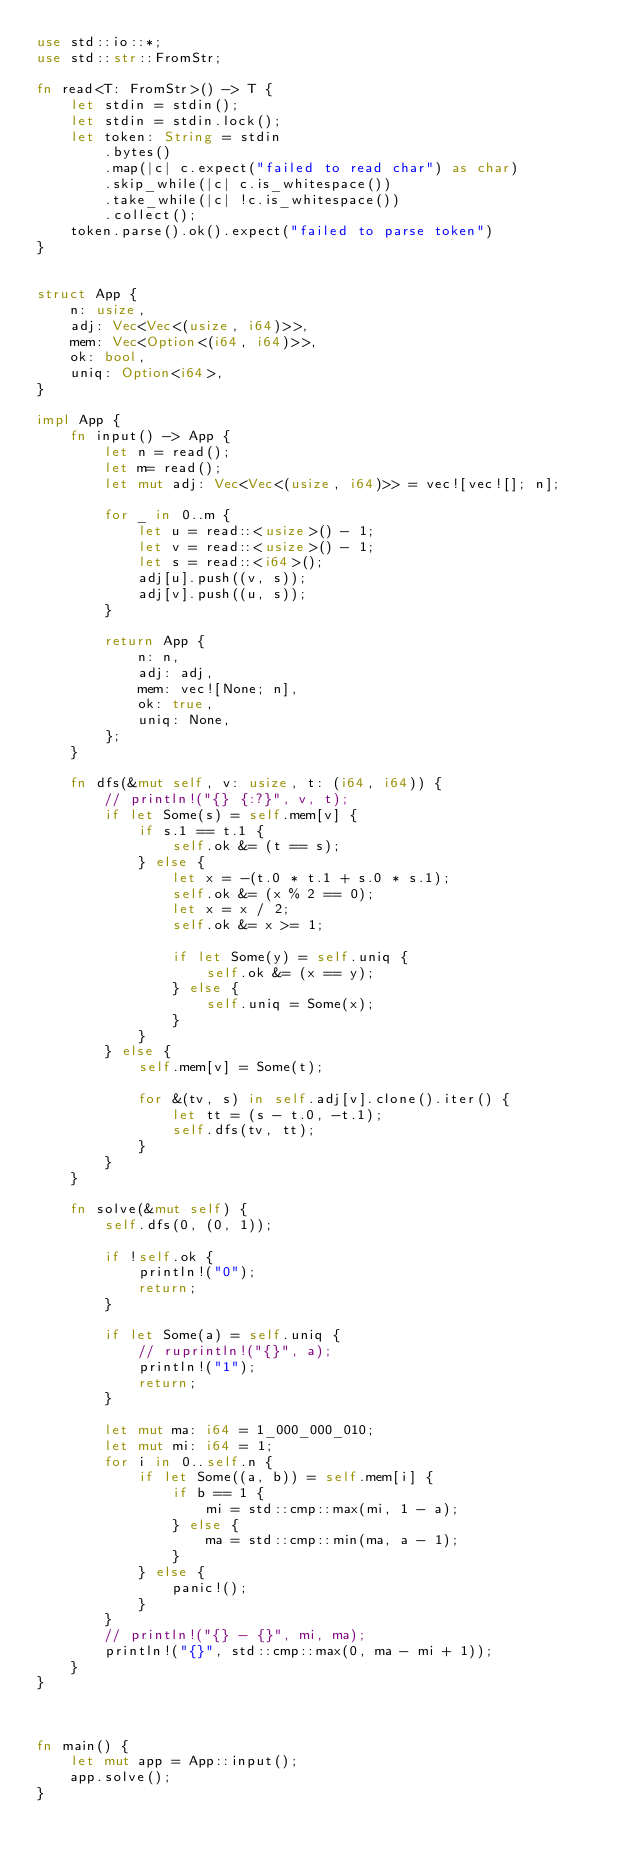<code> <loc_0><loc_0><loc_500><loc_500><_Rust_>use std::io::*;
use std::str::FromStr;

fn read<T: FromStr>() -> T {
    let stdin = stdin();
    let stdin = stdin.lock();
    let token: String = stdin
        .bytes()
        .map(|c| c.expect("failed to read char") as char)
        .skip_while(|c| c.is_whitespace())
        .take_while(|c| !c.is_whitespace())
        .collect();
    token.parse().ok().expect("failed to parse token")
}


struct App {
    n: usize,
    adj: Vec<Vec<(usize, i64)>>,
    mem: Vec<Option<(i64, i64)>>,
    ok: bool,
    uniq: Option<i64>,
}

impl App {
    fn input() -> App {
        let n = read();
        let m= read();
        let mut adj: Vec<Vec<(usize, i64)>> = vec![vec![]; n];

        for _ in 0..m {
            let u = read::<usize>() - 1;
            let v = read::<usize>() - 1;
            let s = read::<i64>();
            adj[u].push((v, s));
            adj[v].push((u, s));
        }

        return App {
            n: n,
            adj: adj,
            mem: vec![None; n],
            ok: true,
            uniq: None,
        };
    }

    fn dfs(&mut self, v: usize, t: (i64, i64)) {
        // println!("{} {:?}", v, t);
        if let Some(s) = self.mem[v] {
            if s.1 == t.1 {
                self.ok &= (t == s);
            } else {
                let x = -(t.0 * t.1 + s.0 * s.1);
                self.ok &= (x % 2 == 0);
                let x = x / 2;
                self.ok &= x >= 1;

                if let Some(y) = self.uniq {
                    self.ok &= (x == y);
                } else {
                    self.uniq = Some(x);
                }
            }
        } else {
            self.mem[v] = Some(t);

            for &(tv, s) in self.adj[v].clone().iter() {
                let tt = (s - t.0, -t.1);
                self.dfs(tv, tt);
            }
        }
    }

    fn solve(&mut self) {
        self.dfs(0, (0, 1));

        if !self.ok {
            println!("0");
            return;
        }

        if let Some(a) = self.uniq {
            // ruprintln!("{}", a);
            println!("1");
            return;
        }

        let mut ma: i64 = 1_000_000_010;
        let mut mi: i64 = 1;
        for i in 0..self.n {
            if let Some((a, b)) = self.mem[i] {
                if b == 1 {
                    mi = std::cmp::max(mi, 1 - a);
                } else {
                    ma = std::cmp::min(ma, a - 1);
                }
            } else {
                panic!();
            }
        }
        // println!("{} - {}", mi, ma);
        println!("{}", std::cmp::max(0, ma - mi + 1));
    }
}



fn main() {
    let mut app = App::input();
    app.solve();
}
</code> 